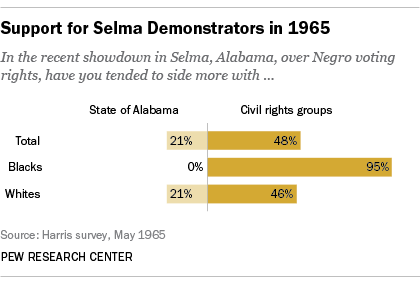Indicate a few pertinent items in this graphic. The largest yellow bar represents 95% of the total value displayed. The product of the largest darker yellow bar and the sum of the two smallest darker yellow bars is 8,930. 